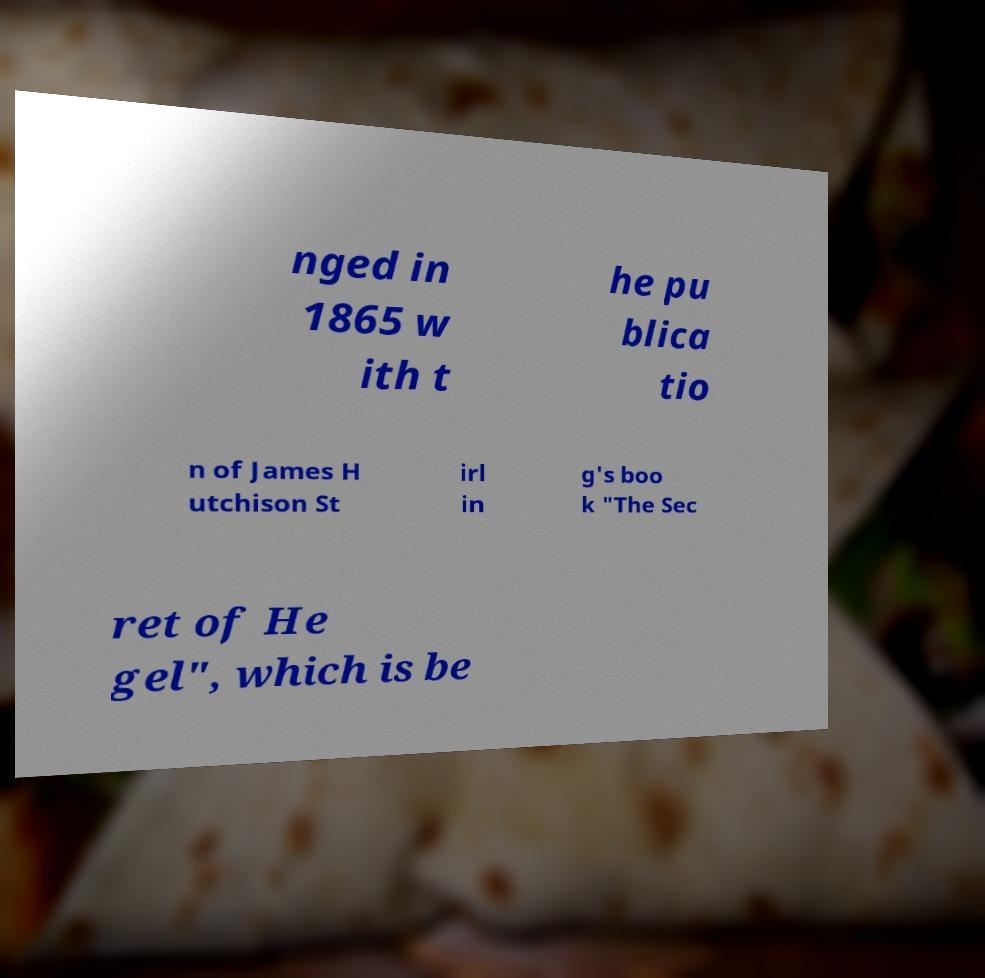There's text embedded in this image that I need extracted. Can you transcribe it verbatim? nged in 1865 w ith t he pu blica tio n of James H utchison St irl in g's boo k "The Sec ret of He gel", which is be 